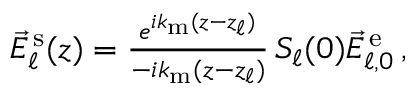Convert formula to latex. <formula><loc_0><loc_0><loc_500><loc_500>\begin{array} { r } { \vec { E } _ { \ell } ^ { \, s } ( z ) = \frac { e ^ { i k _ { m } ( z - z _ { \ell } ) } } { - i k _ { m } ( z - z _ { \ell } ) } \, S _ { \ell } ( 0 ) \vec { E } _ { \ell , 0 } ^ { \, e } \, , } \end{array}</formula> 